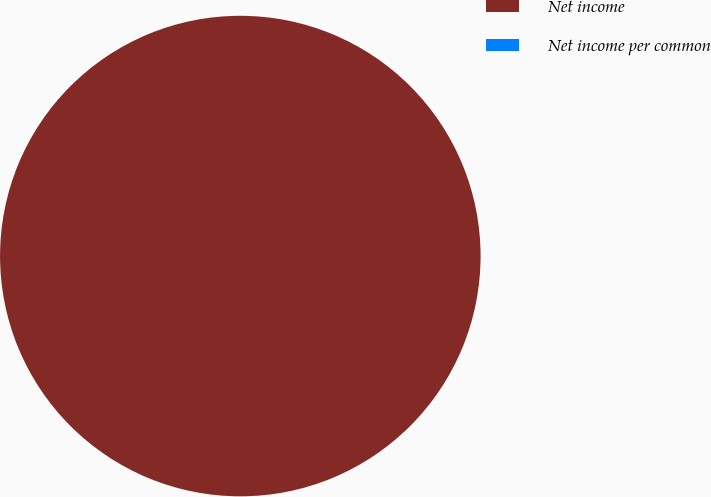Convert chart. <chart><loc_0><loc_0><loc_500><loc_500><pie_chart><fcel>Net income<fcel>Net income per common<nl><fcel>100.0%<fcel>0.0%<nl></chart> 